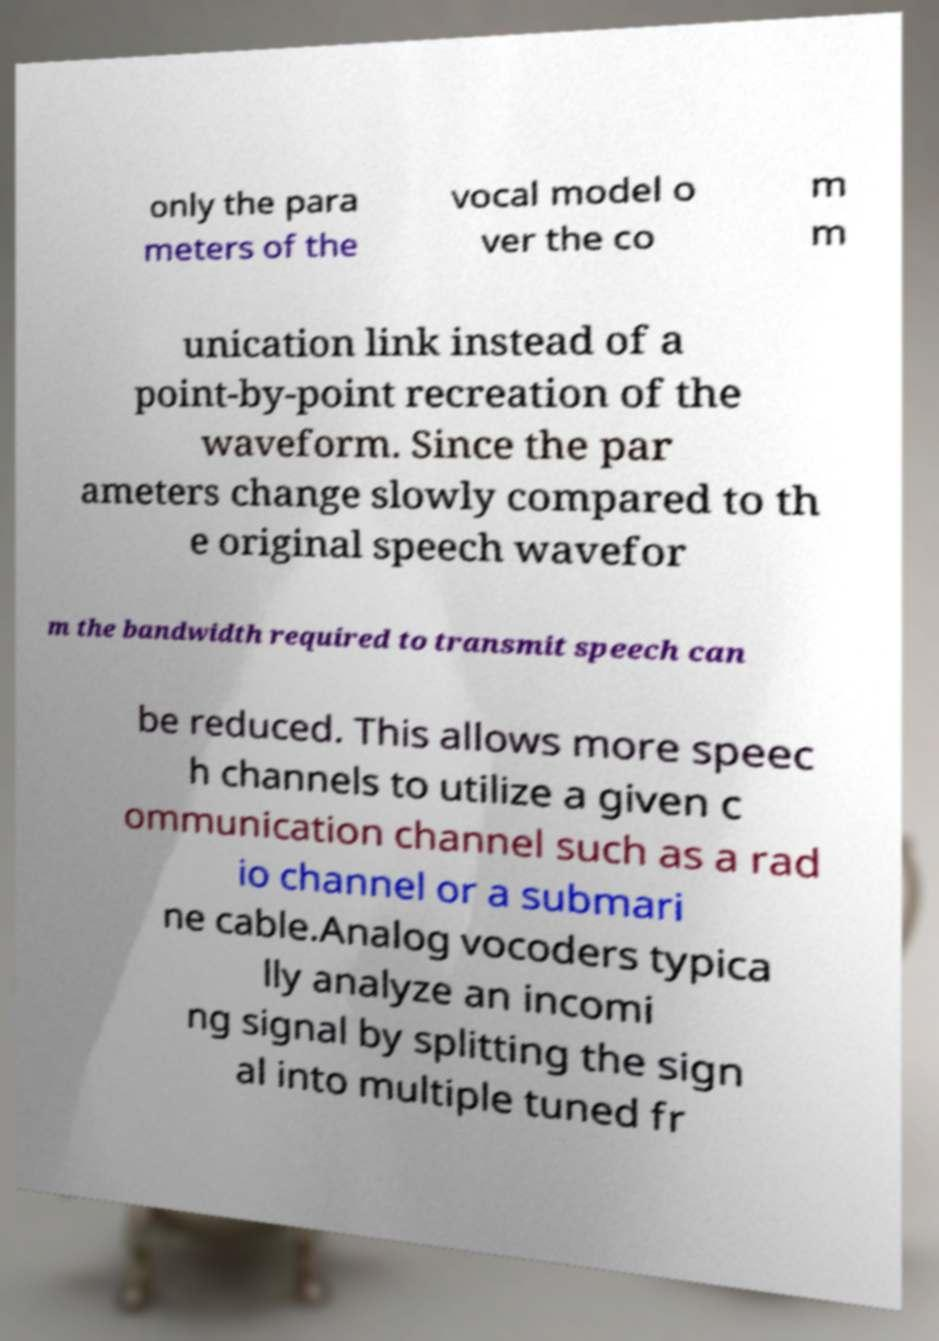What messages or text are displayed in this image? I need them in a readable, typed format. only the para meters of the vocal model o ver the co m m unication link instead of a point-by-point recreation of the waveform. Since the par ameters change slowly compared to th e original speech wavefor m the bandwidth required to transmit speech can be reduced. This allows more speec h channels to utilize a given c ommunication channel such as a rad io channel or a submari ne cable.Analog vocoders typica lly analyze an incomi ng signal by splitting the sign al into multiple tuned fr 